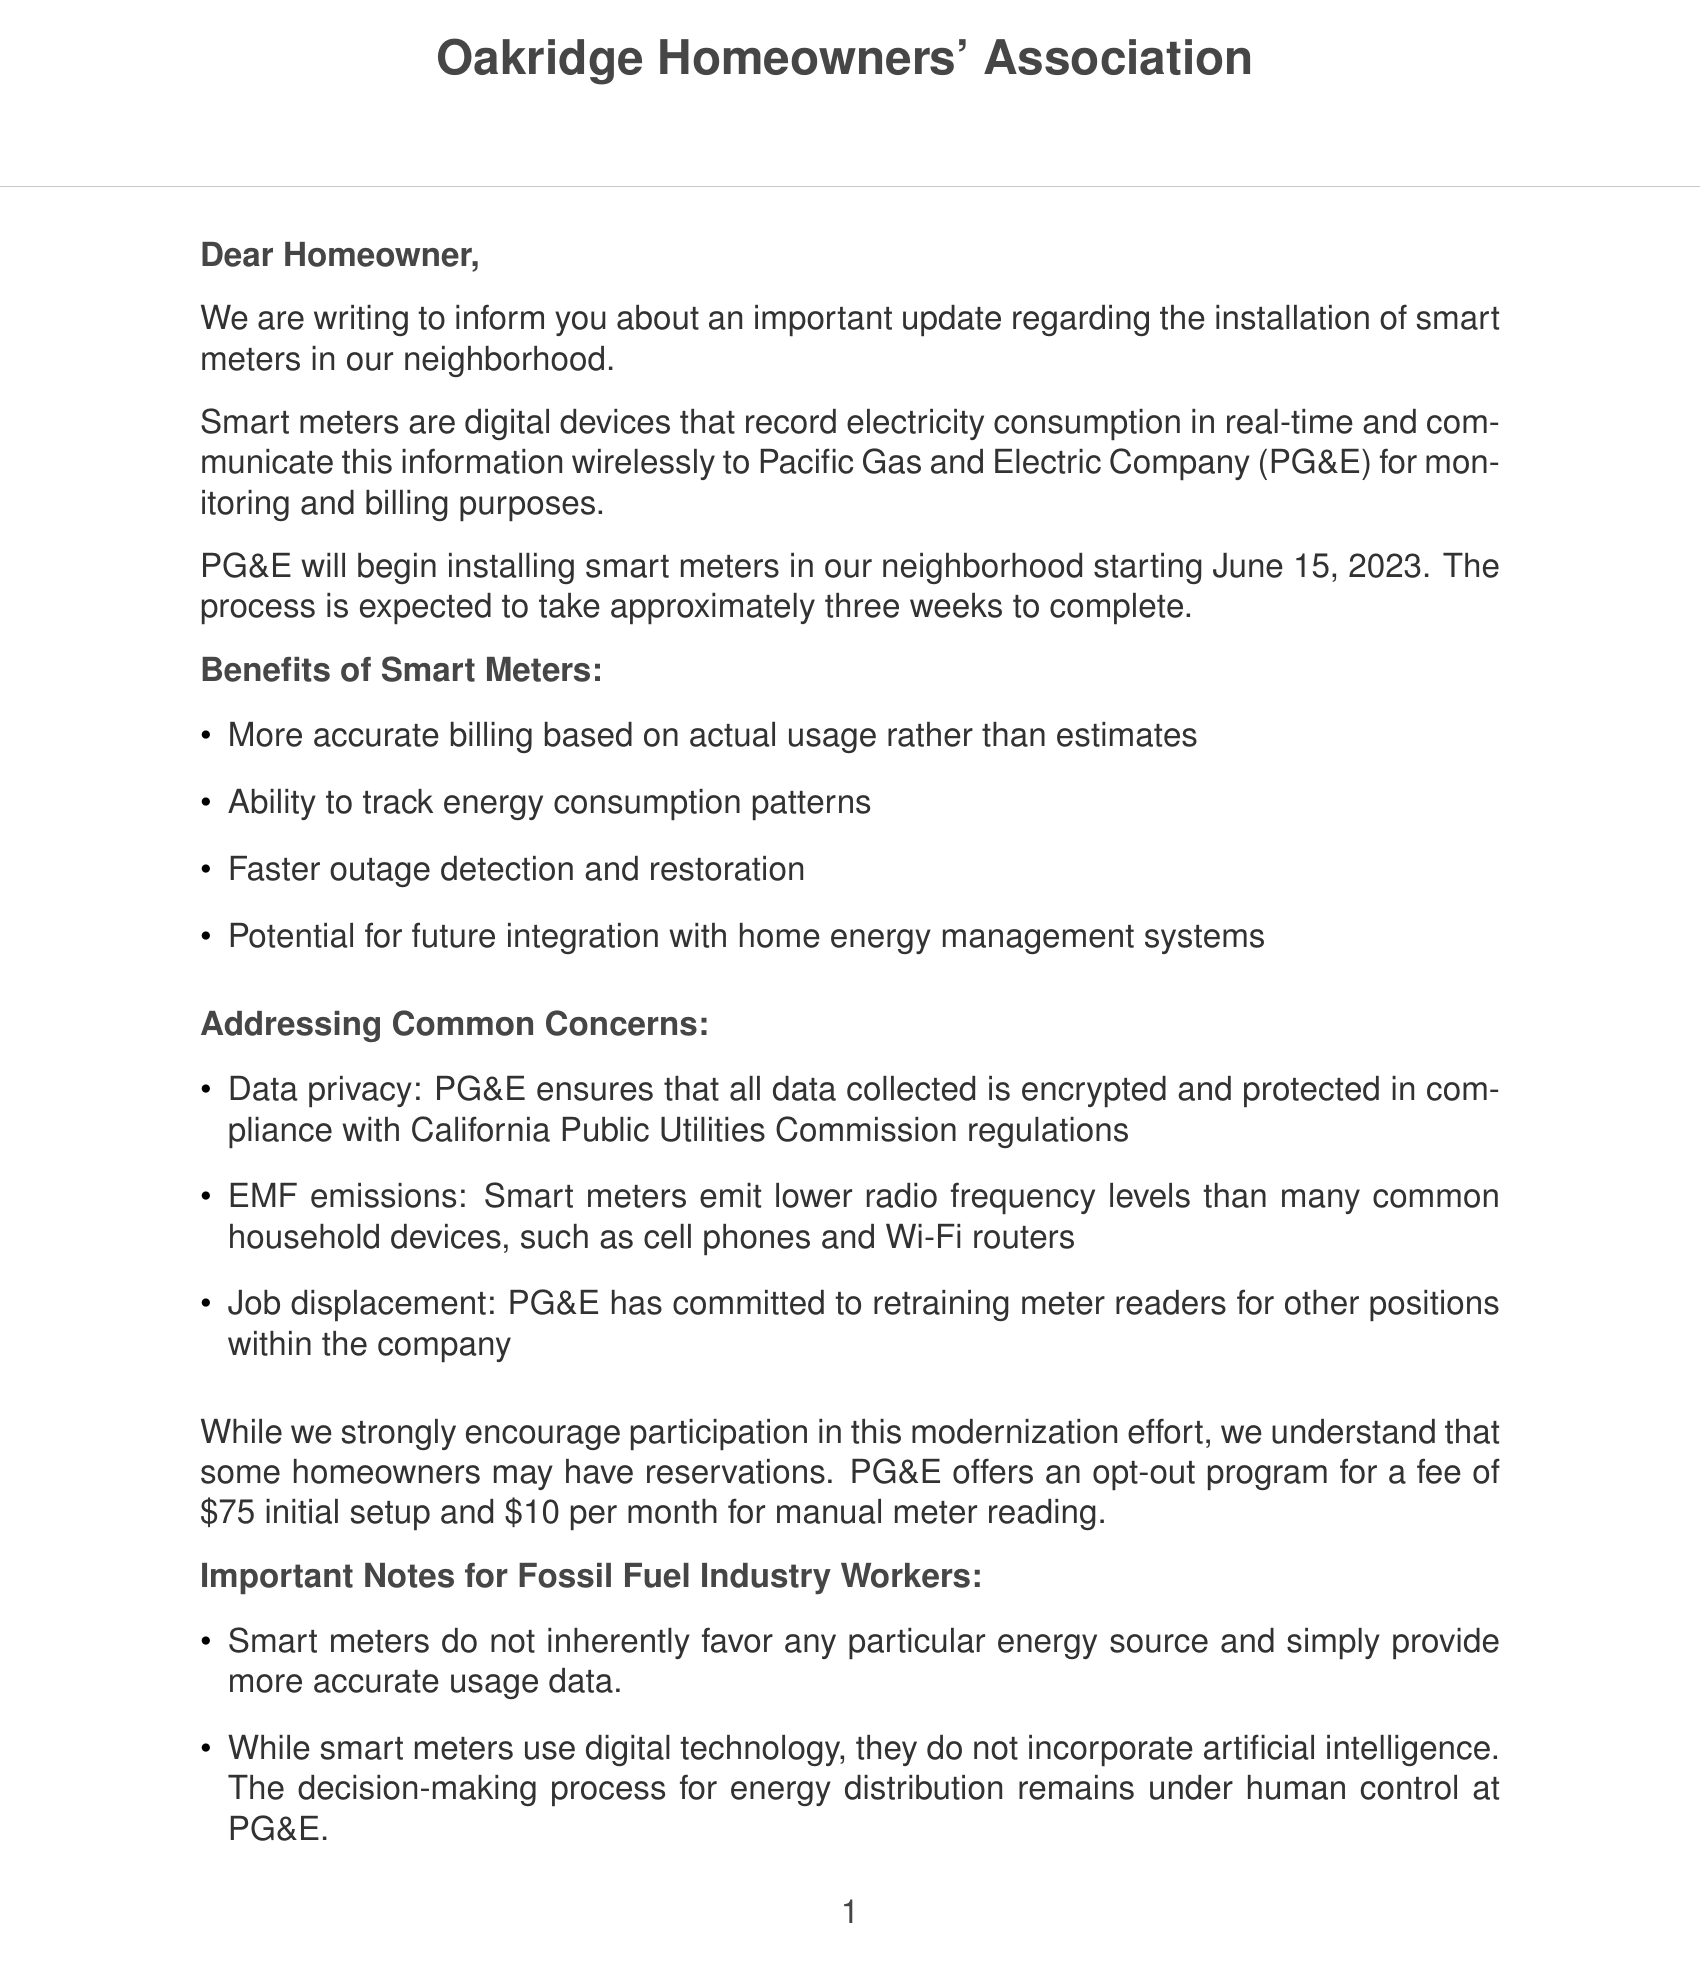What is the installation start date for smart meters? The installation process for smart meters will begin on June 15, 2023, as stated in the letter.
Answer: June 15, 2023 How long will the installation take? The letter mentions that the installation process is expected to take approximately three weeks to complete.
Answer: approximately three weeks Who should be contacted for HOA-related questions? The contact information in the document specifies that questions or concerns should be directed to Sarah Thompson, the HOA manager.
Answer: Sarah Thompson What is the fee for opting out of the smart meter program? The document outlines that opting out of the smart meter program has an initial setup fee of $75 and a monthly fee of $10 for manual meter reading.
Answer: $75 initial setup and $10 per month What does PG&E say about data privacy? The letter states that PG&E ensures all collected data is encrypted and protected in compliance with regulations.
Answer: encrypted and protected What are the benefits of installing smart meters? Benefits listed in the document include accurate billing based on actual usage, tracking energy consumption patterns, and faster outage detection.
Answer: Accurate billing based on actual usage What level of EMF emissions do smart meters have compared to household devices? The letter clarifies that smart meters emit lower radio frequency levels than many common household devices.
Answer: lower radio frequency levels Can smart meters integrate with other systems? The letter mentions the potential for future integration with home energy management systems as a benefit of smart meters.
Answer: Yes, with home energy management systems What is the final message from the HOA regarding the installation? The letter closes by expressing appreciation for understanding and cooperation during the modernization effort.
Answer: appreciation for understanding and cooperation 